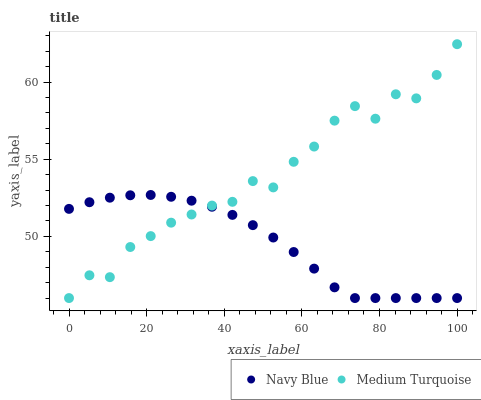Does Navy Blue have the minimum area under the curve?
Answer yes or no. Yes. Does Medium Turquoise have the maximum area under the curve?
Answer yes or no. Yes. Does Medium Turquoise have the minimum area under the curve?
Answer yes or no. No. Is Navy Blue the smoothest?
Answer yes or no. Yes. Is Medium Turquoise the roughest?
Answer yes or no. Yes. Is Medium Turquoise the smoothest?
Answer yes or no. No. Does Navy Blue have the lowest value?
Answer yes or no. Yes. Does Medium Turquoise have the highest value?
Answer yes or no. Yes. Does Medium Turquoise intersect Navy Blue?
Answer yes or no. Yes. Is Medium Turquoise less than Navy Blue?
Answer yes or no. No. Is Medium Turquoise greater than Navy Blue?
Answer yes or no. No. 